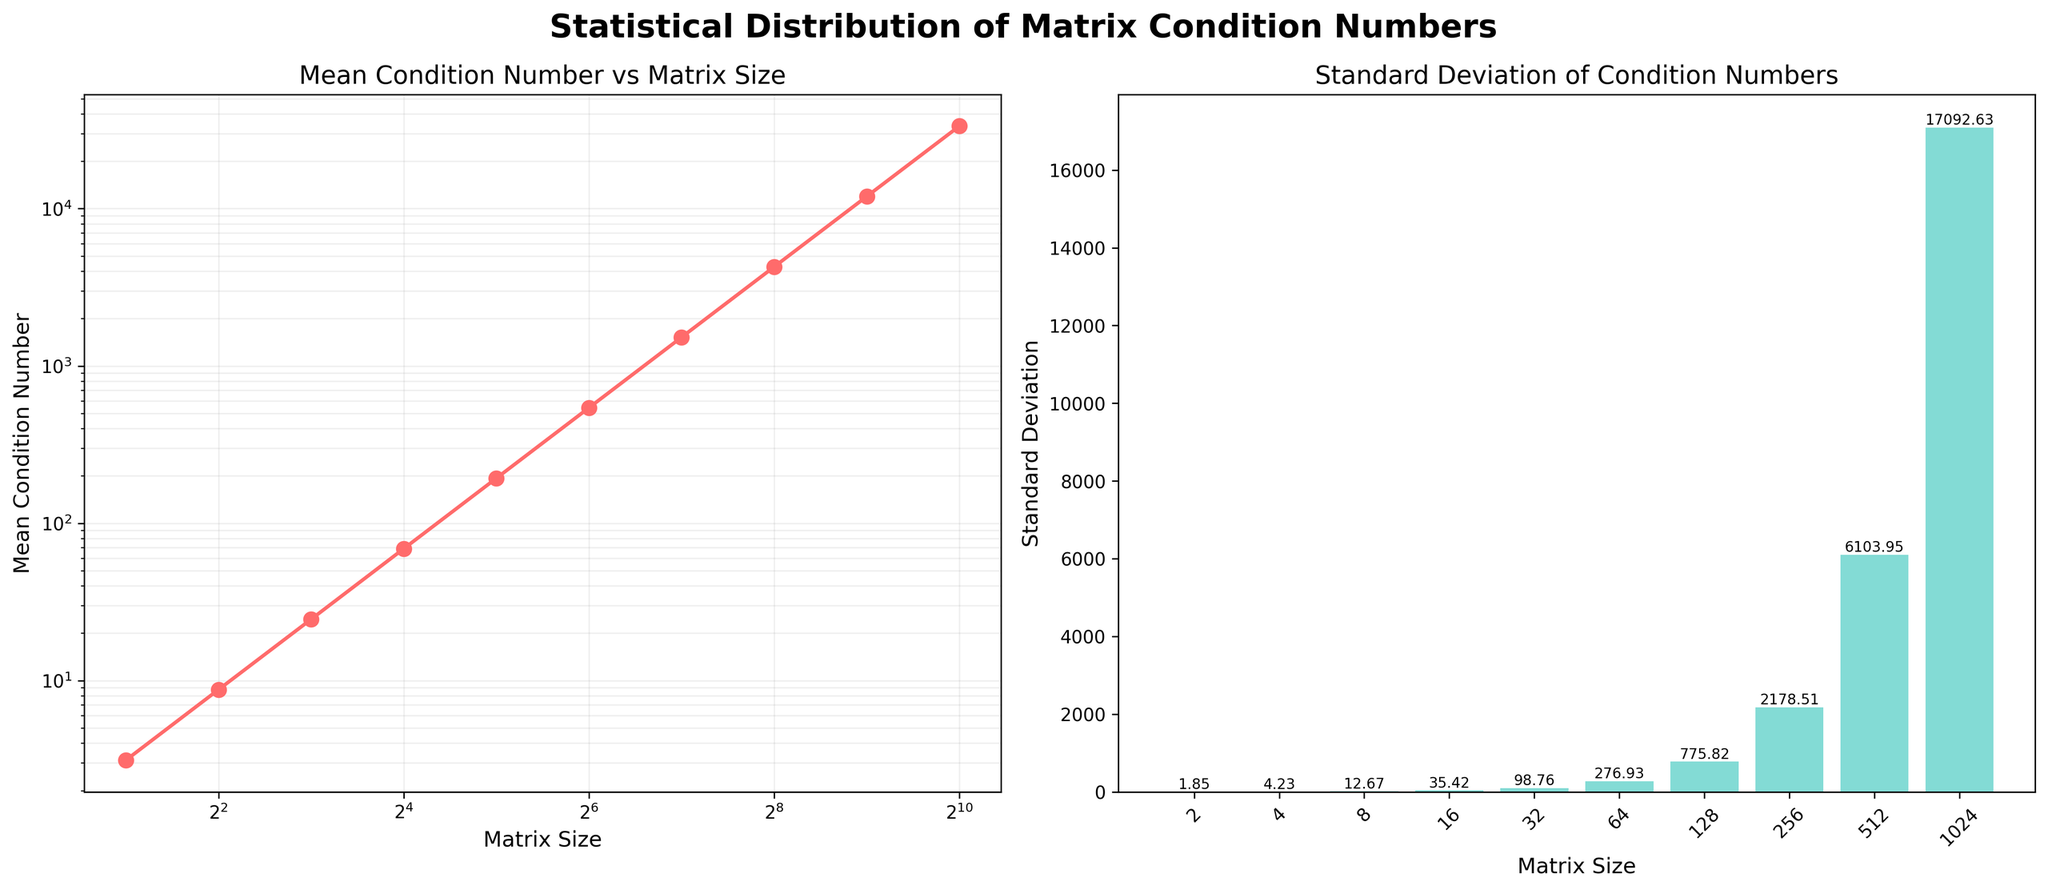What is the matrix size with the lowest mean condition number? The dataset lists matrix sizes along with their mean condition numbers. By inspecting the first subplot, we can identify the lowest mean condition number value. The plot shows that the smallest mean is for the matrix size 2.
Answer: 2 Which two matrix sizes have the highest and lowest standard deviations of condition numbers? The second subplot shows bars for standard deviations for various matrix sizes. The highest bar represents matrix size with the maximum standard deviation, while the shortest bar represents the matrix size with the minimum standard deviation. The highest standard deviation is for matrix size 1024, and the lowest is for matrix size 2.
Answer: 1024 and 2 How does the standard deviation of condition numbers change as matrix size increases? Observing the second subplot, the standard deviation values generally increase as the matrix size increases. The heights of the bars increase from left to right across most matrix sizes, showing that larger matrices have higher variability in condition numbers.
Answer: Increases By what factor does the mean condition number change from matrix size 2 to matrix size 1024? From the first subplot, the mean condition number for size 2 is 3.12, and for size 1024 it is 33485.16. To find the factor of change, we calculate \( \frac{33485.16}{3.12} \).
Answer: 10732.76 Is there a proportional relationship between the mean and standard deviation of condition numbers for any matrix size? By comparing the data points visually in both subplots, we see that generally both the mean and standard deviation are increasing together with matrix size, suggesting some form of proportional relationship, but this is more of an observational trend rather than a precise proportional relationship shown directly by the plots.
Answer: Yes, a trend What is the increase in the mean condition number from matrix size 4 to matrix size 8? From the first subplot, the mean condition number for size 4 is 8.76 and for size 8 it is 24.53. To find the difference, we subtract 8.76 from 24.53.
Answer: 15.77 At which matrix size does the mean condition number first exceed 1000? Referring to the first subplot, we note the values for the mean condition numbers and identify the first matrix size for which this value exceeds 1000. This occurs at size 128.
Answer: 128 For which matrix size is the ratio of mean condition number to standard deviation closest to 1? We calculate the ratio of mean condition number to standard deviation for each matrix size. Visually inspecting these values, we see which ratio is closest to 1. For matrix size 32, with mean 193.25 and standard deviation 98.76, the ratio is closest to 1.
Answer: 32 Which subplot shows the more consistent growth pattern of the values? Both subplots represent different measures, but the first subplot (mean condition number vs. matrix size) shows a more consistent exponential growth pattern as the size increases, especially noted in the log-log scale fashion.
Answer: Mean condition number vs. matrix size Is there any matrix size for which the standard deviation is greater than half of the mean condition number? We examine the values of the second subplot, noting if any standard deviation value surpasses half of the respective mean value seen in the first subplot. By inspecting the corresponding values, no matrix size satisfies this condition.
Answer: No 